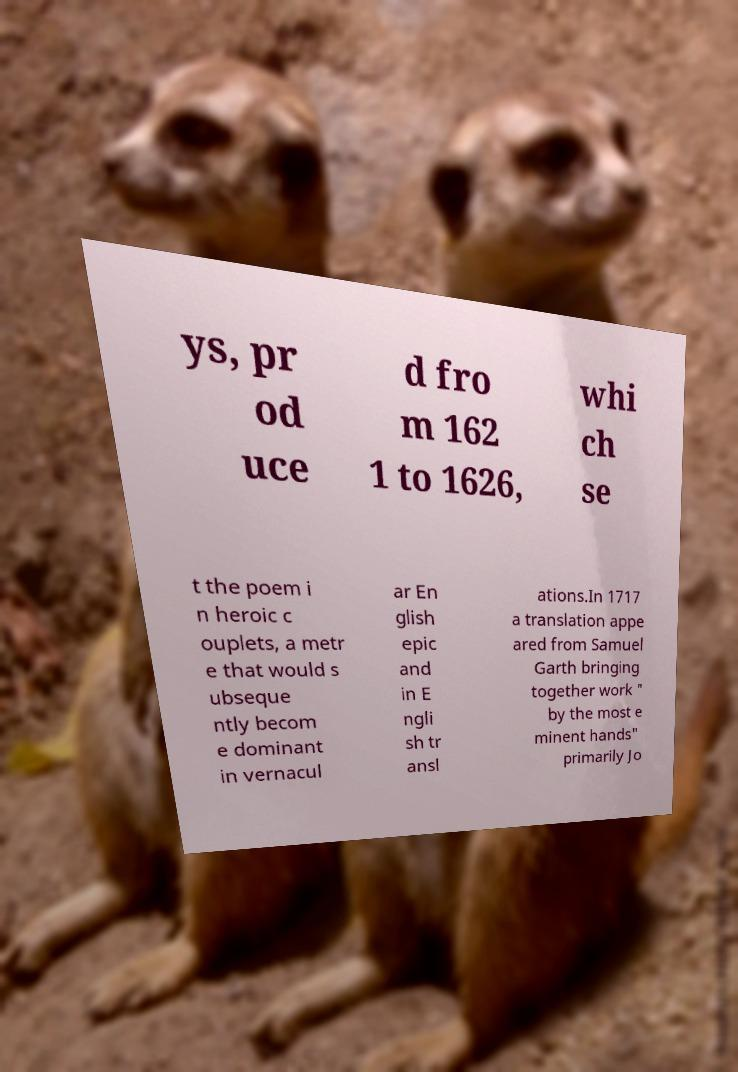I need the written content from this picture converted into text. Can you do that? ys, pr od uce d fro m 162 1 to 1626, whi ch se t the poem i n heroic c ouplets, a metr e that would s ubseque ntly becom e dominant in vernacul ar En glish epic and in E ngli sh tr ansl ations.In 1717 a translation appe ared from Samuel Garth bringing together work " by the most e minent hands" primarily Jo 